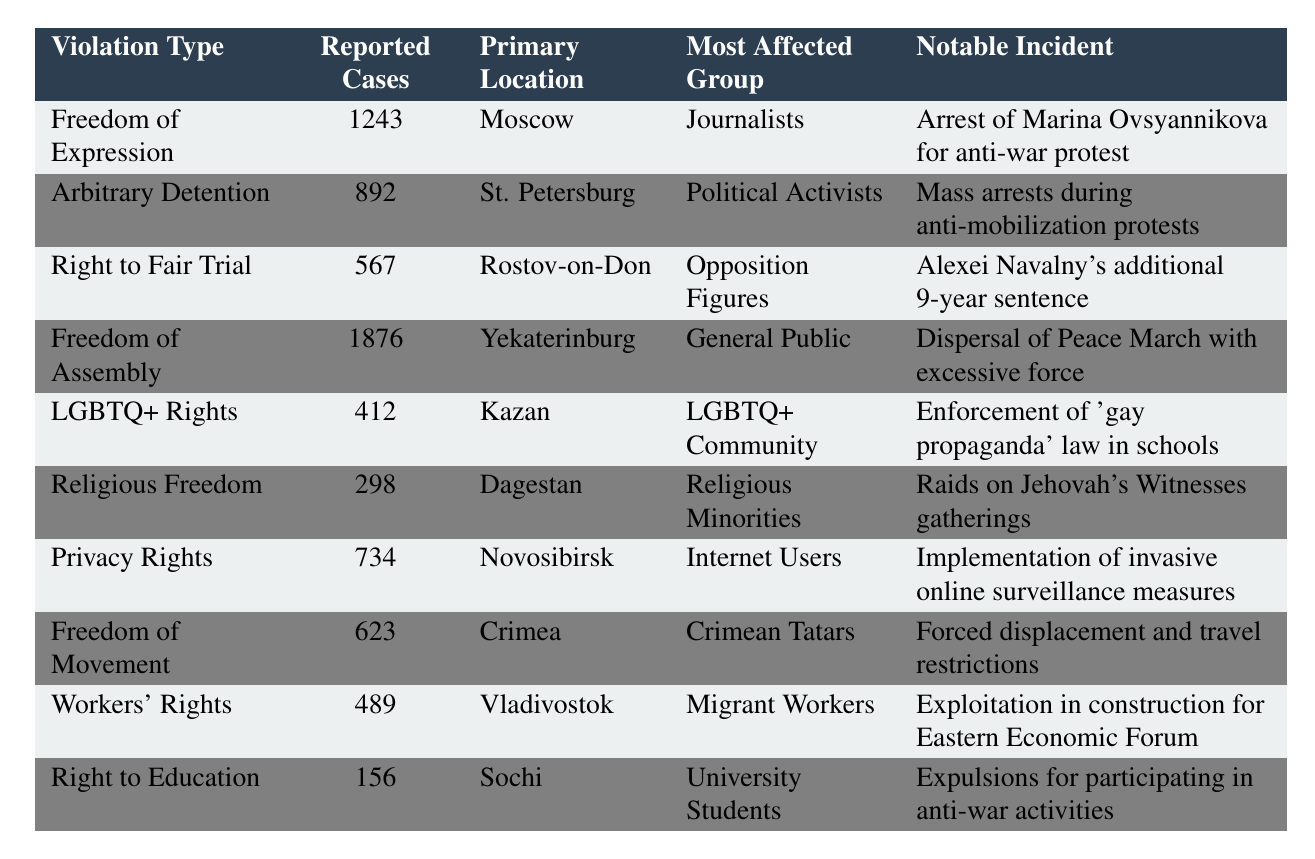What is the most common type of human rights violation reported in 2022? The table shows that 'Freedom of Assembly' has the highest number of reported cases at 1876.
Answer: Freedom of Assembly How many reported cases are there for LGBTQ+ Rights? The table states that there were 412 reported cases under the category of LGBTQ+ Rights.
Answer: 412 In which location were the majority of the human rights violations reported? By comparing the numbers, Yekaterinburg has the highest reported cases at 1876, indicating it as the primary location for the majority of human rights violations.
Answer: Yekaterinburg Which group was most affected by arbitrary detention incidents? According to the table, 'Political Activists' are listed as the most affected group for arbitrary detention with 892 reported cases.
Answer: Political Activists What notable incident occurred related to the right to a fair trial? The table mentions Alexei Navalny's additional 9-year sentence as a notable incident linked to the right to a fair trial.
Answer: Alexei Navalny's additional 9-year sentence Are the reported cases of 'Freedom of Expression' higher than those of 'Privacy Rights'? The table shows 1243 cases for Freedom of Expression and 734 for Privacy Rights. Thus, Freedom of Expression cases are indeed higher.
Answer: Yes How many violations were reported for Workers' Rights and Freedom of Movement combined? Adding the reported cases for Workers' Rights (489) and Freedom of Movement (623): 489 + 623 = 1112.
Answer: 1112 In which location were the fewest human rights violations reported? By examining the numbers, Sochi has the lowest reported cases at 156 for the right to education, making it the location with the fewest violations.
Answer: Sochi What percentage of the total reported cases do Arbitrary Detention cases represent? The total reported cases can be calculated as: 1243 + 892 + 567 + 1876 + 412 + 298 + 734 + 623 + 489 + 156 = 6124. Then, dividing Arbitrary Detention cases (892) by the total (6124) and multiplying by 100 gives approximately 14.6%.
Answer: 14.6% What is the difference in reported cases between Freedom of Assembly and Freedom of Expression? Freedom of Assembly has 1876 reported cases while Freedom of Expression has 1243. The difference is 1876 - 1243 = 633.
Answer: 633 Which specific group experienced the least reported cases among the listed violations? The table indicates that 'Right to Education' affected 'University Students' with the least reported cases at 156.
Answer: University Students 